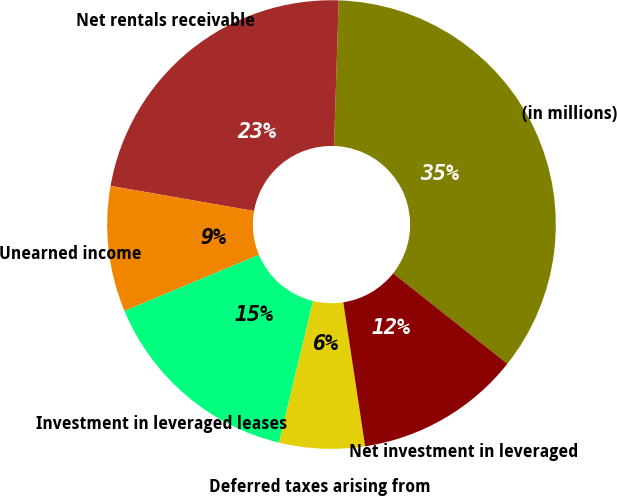<chart> <loc_0><loc_0><loc_500><loc_500><pie_chart><fcel>(in millions)<fcel>Net rentals receivable<fcel>Unearned income<fcel>Investment in leveraged leases<fcel>Deferred taxes arising from<fcel>Net investment in leveraged<nl><fcel>35.14%<fcel>22.75%<fcel>9.05%<fcel>14.95%<fcel>6.15%<fcel>11.95%<nl></chart> 